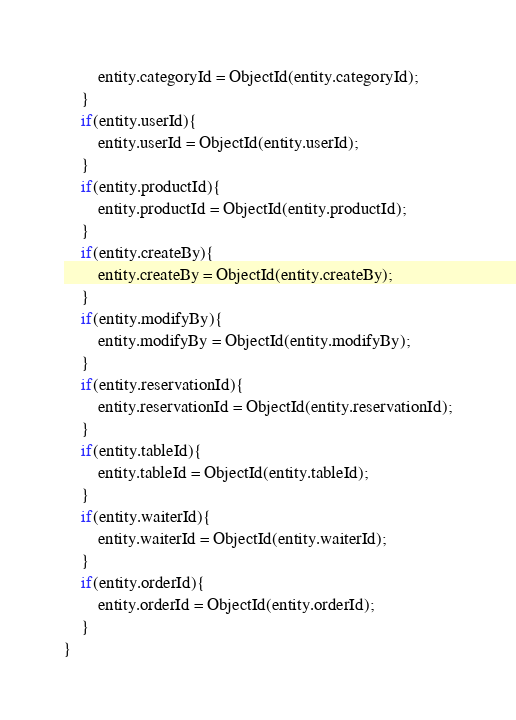<code> <loc_0><loc_0><loc_500><loc_500><_JavaScript_>        entity.categoryId = ObjectId(entity.categoryId);
    }
    if(entity.userId){
        entity.userId = ObjectId(entity.userId);
    }
    if(entity.productId){
        entity.productId = ObjectId(entity.productId);
    }
    if(entity.createBy){
        entity.createBy = ObjectId(entity.createBy);
    }
    if(entity.modifyBy){
        entity.modifyBy = ObjectId(entity.modifyBy);
    }
    if(entity.reservationId){
        entity.reservationId = ObjectId(entity.reservationId);
    }
    if(entity.tableId){
        entity.tableId = ObjectId(entity.tableId);
    }
    if(entity.waiterId){
        entity.waiterId = ObjectId(entity.waiterId);
    }
    if(entity.orderId){
        entity.orderId = ObjectId(entity.orderId);
    }
}</code> 